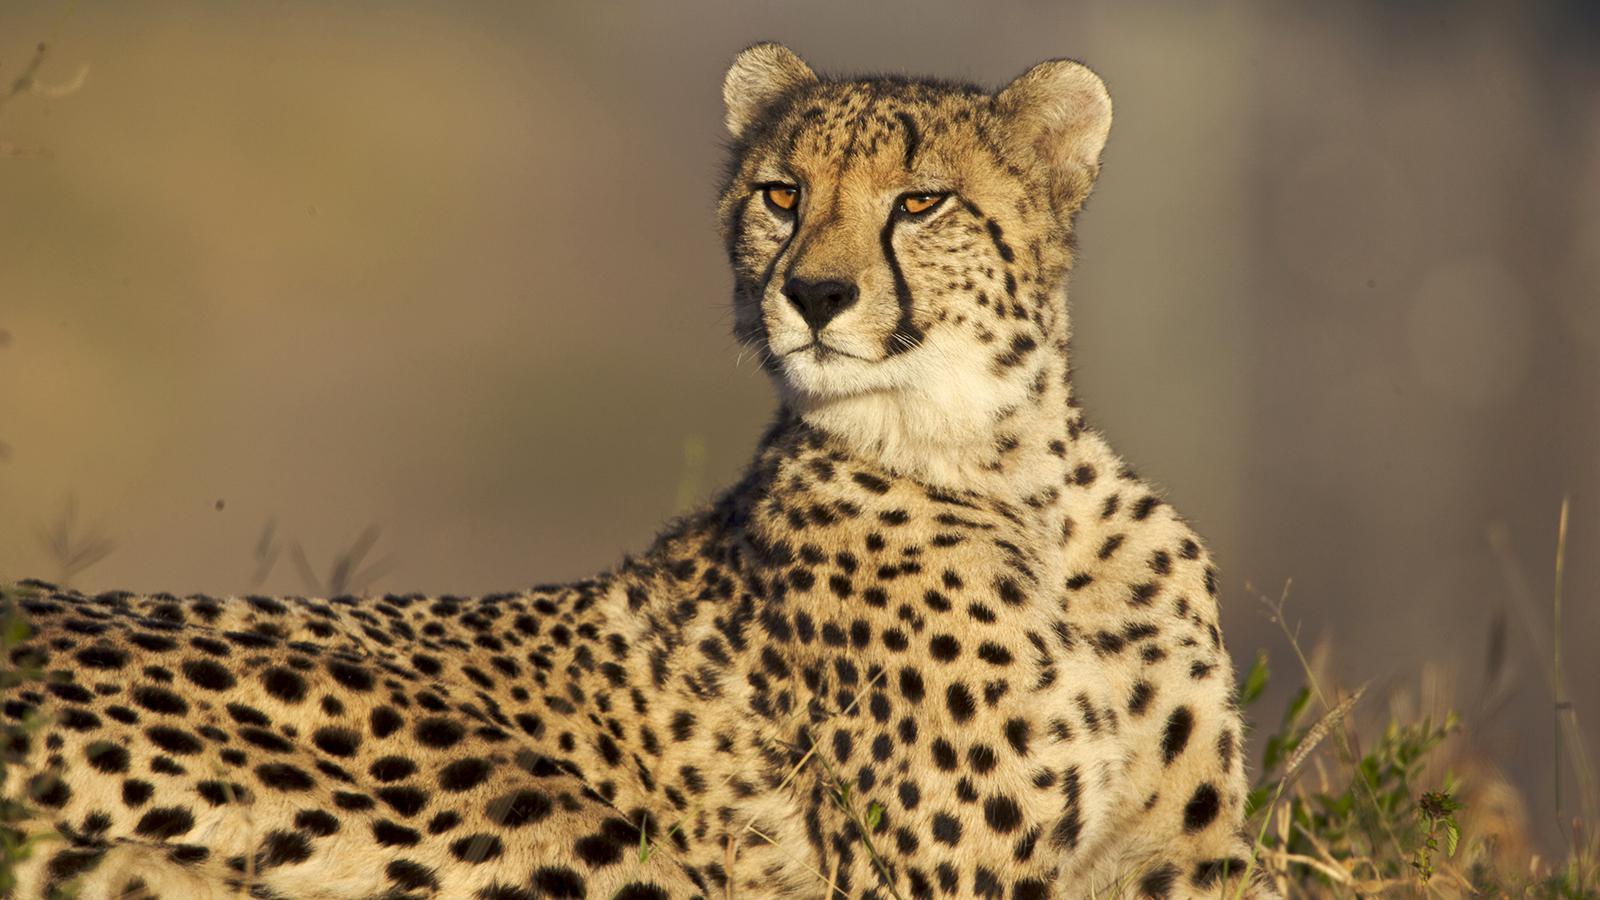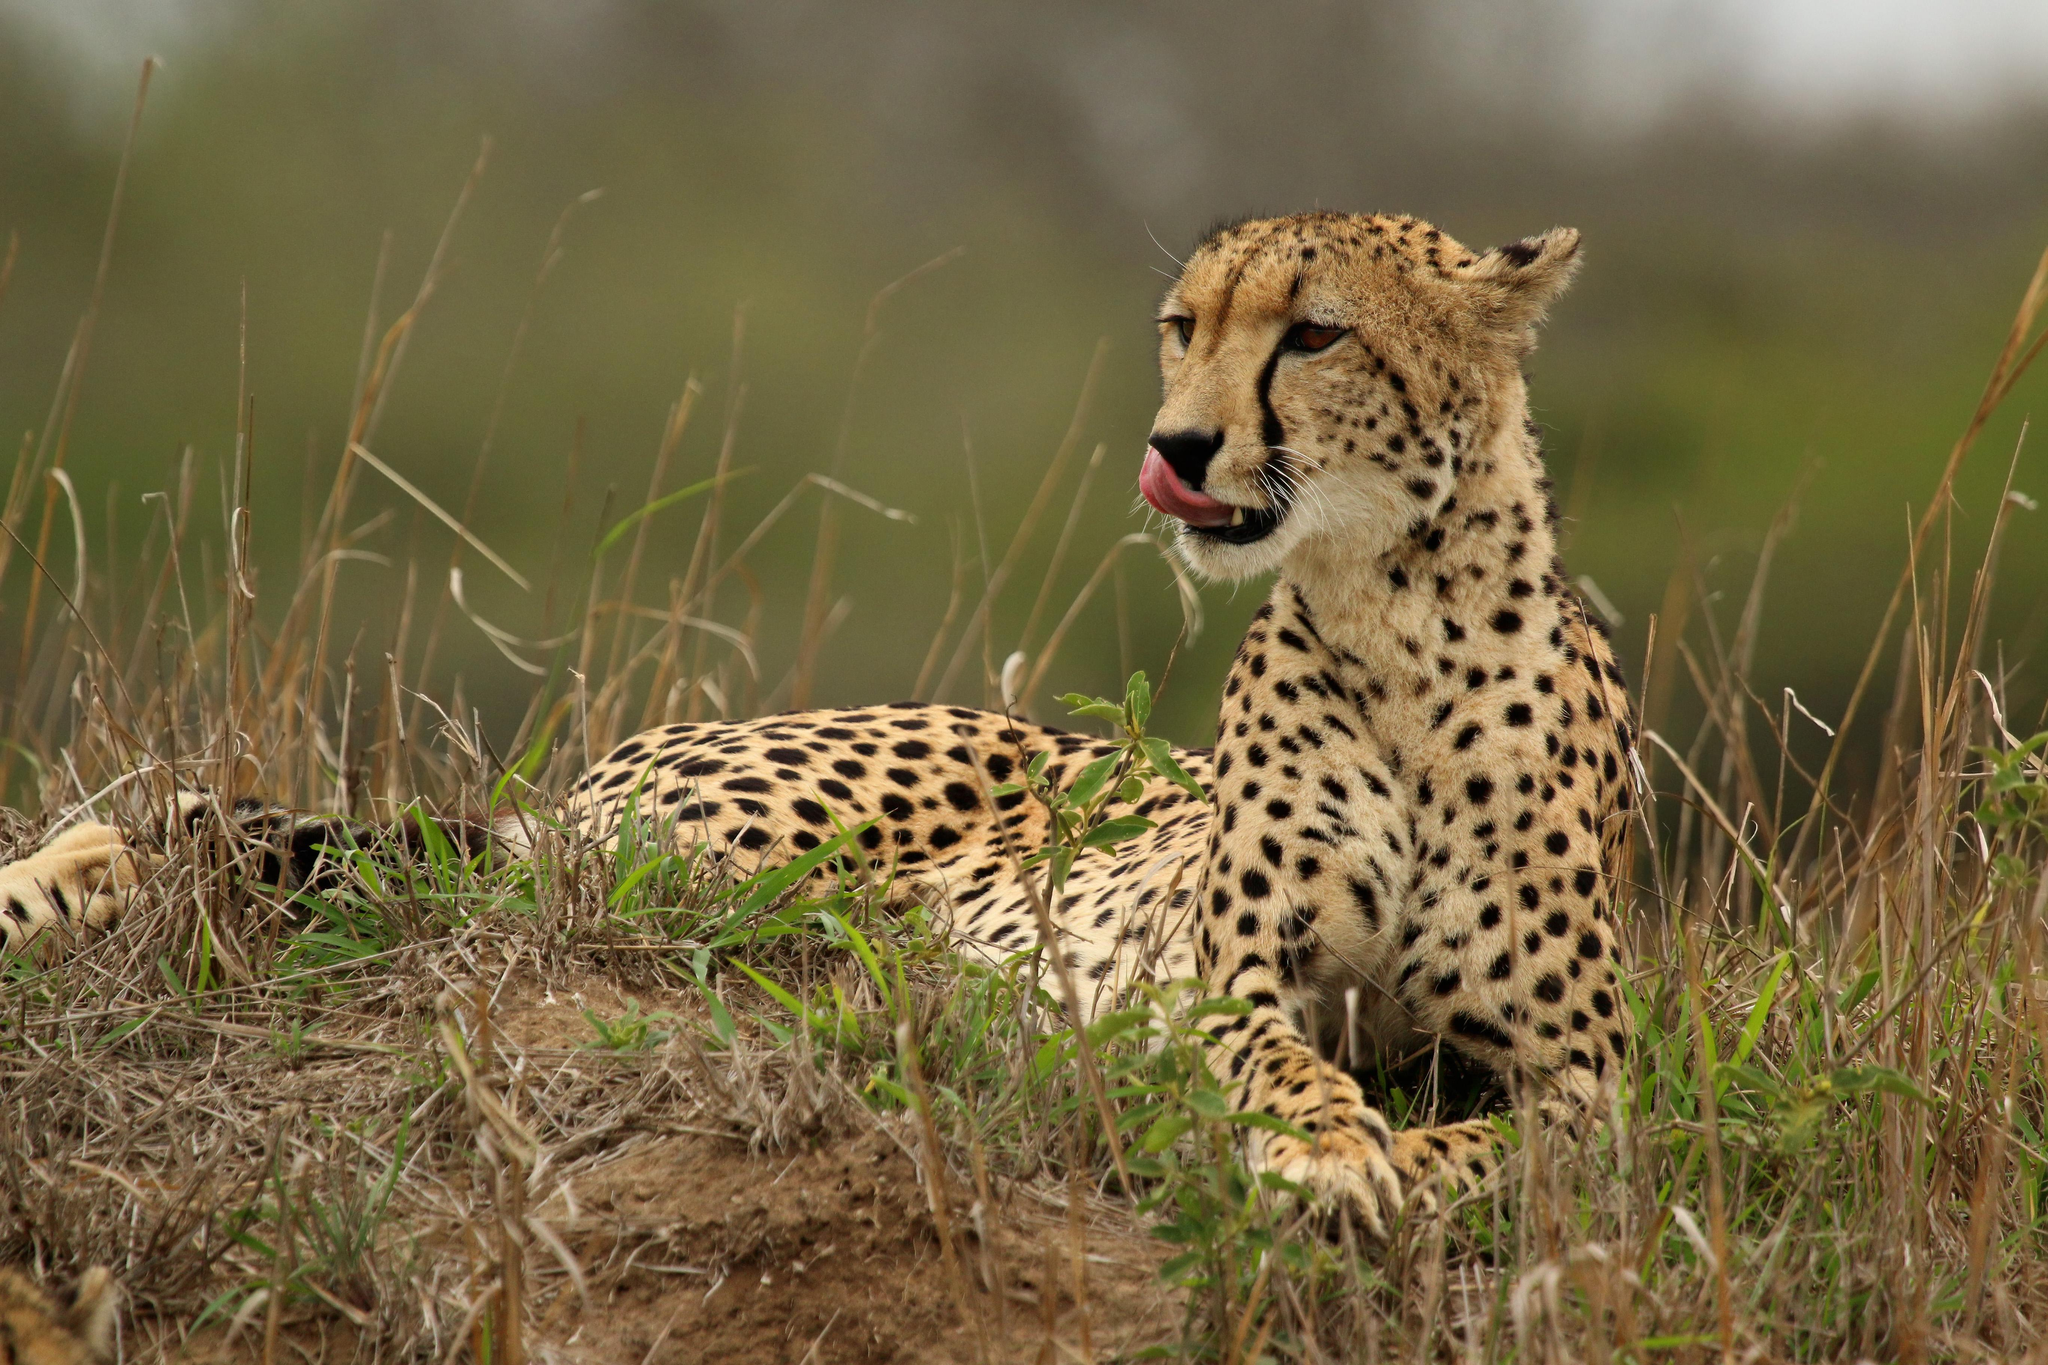The first image is the image on the left, the second image is the image on the right. Examine the images to the left and right. Is the description "At least one cheetah is laying down." accurate? Answer yes or no. Yes. 